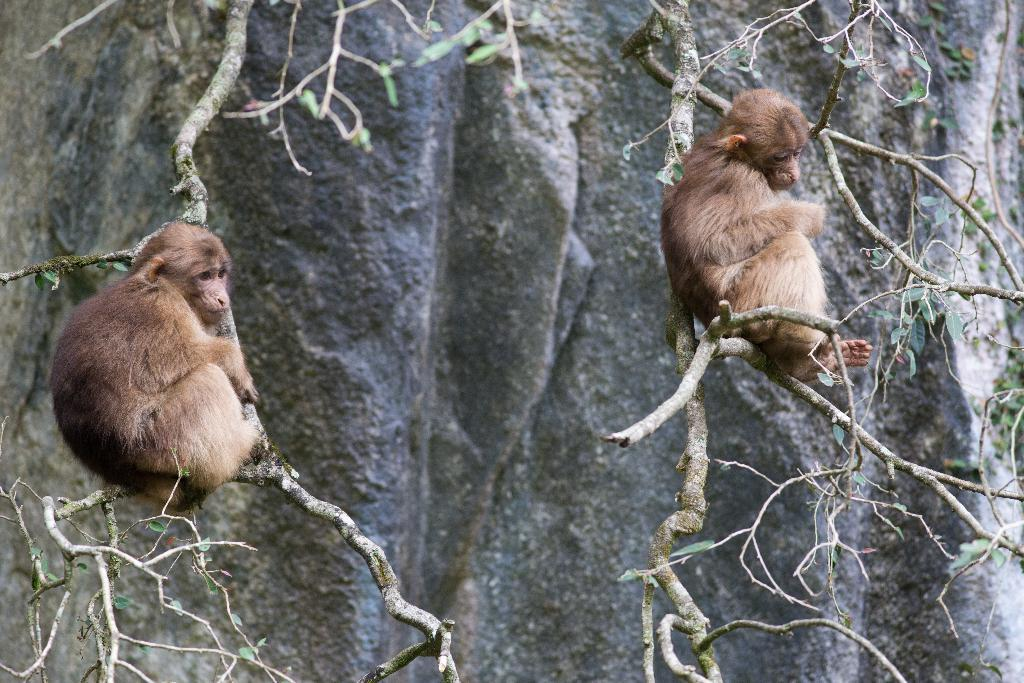How many monkeys are in the image? There are two monkeys in the image. What are the monkeys doing in the image? The monkeys are hanging on the branch of a tree. What can be seen in the background of the image? There is a hill visible in the background of the image. Can you see the fang of the snake in the image? There is no snake present in the image, so it is not possible to see the fang of a snake. 